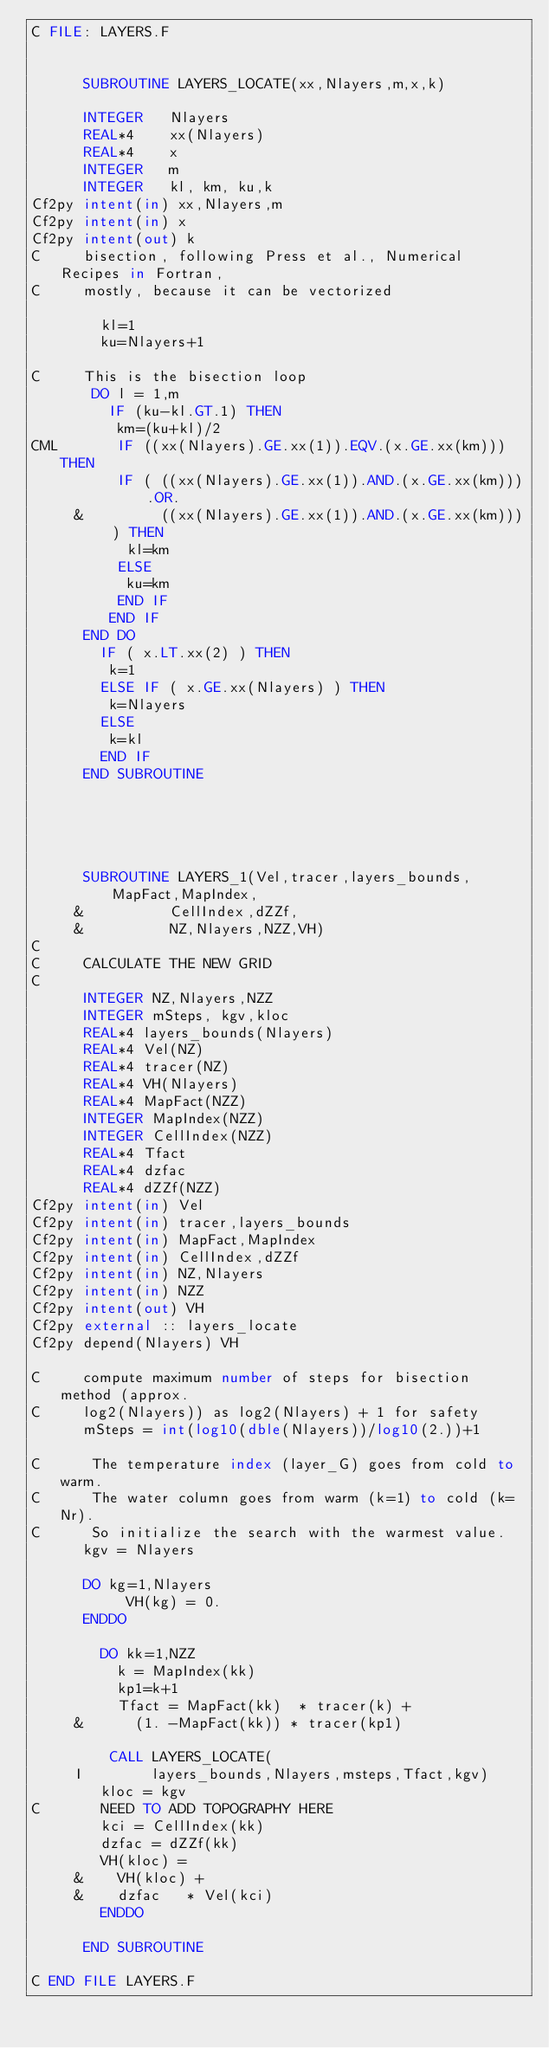<code> <loc_0><loc_0><loc_500><loc_500><_FORTRAN_>C FILE: LAYERS.F


      SUBROUTINE LAYERS_LOCATE(xx,Nlayers,m,x,k)

      INTEGER   Nlayers
      REAL*4    xx(Nlayers)
      REAL*4    x
      INTEGER   m
      INTEGER   kl, km, ku,k
Cf2py intent(in) xx,Nlayers,m
Cf2py intent(in) x
Cf2py intent(out) k
C     bisection, following Press et al., Numerical Recipes in Fortran,
C     mostly, because it can be vectorized

        kl=1
        ku=Nlayers+1
        
C     This is the bisection loop
       DO l = 1,m
         IF (ku-kl.GT.1) THEN
          km=(ku+kl)/2
CML       IF ((xx(Nlayers).GE.xx(1)).EQV.(x.GE.xx(km))) THEN
          IF ( ((xx(Nlayers).GE.xx(1)).AND.(x.GE.xx(km))).OR.
     &         ((xx(Nlayers).GE.xx(1)).AND.(x.GE.xx(km))) ) THEN
           kl=km
          ELSE
           ku=km
          END IF
         END IF
      END DO
        IF ( x.LT.xx(2) ) THEN
         k=1
        ELSE IF ( x.GE.xx(Nlayers) ) THEN
         k=Nlayers
        ELSE
         k=kl
        END IF
      END SUBROUTINE





      SUBROUTINE LAYERS_1(Vel,tracer,layers_bounds,MapFact,MapIndex,
     &          CellIndex,dZZf,
     &          NZ,Nlayers,NZZ,VH)
C     
C     CALCULATE THE NEW GRID
C
      INTEGER NZ,Nlayers,NZZ
      INTEGER mSteps, kgv,kloc
      REAL*4 layers_bounds(Nlayers)
      REAL*4 Vel(NZ)
      REAL*4 tracer(NZ)
      REAL*4 VH(Nlayers)
      REAL*4 MapFact(NZZ)
      INTEGER MapIndex(NZZ)
      INTEGER CellIndex(NZZ)
      REAL*4 Tfact
      REAL*4 dzfac
      REAL*4 dZZf(NZZ)
Cf2py intent(in) Vel
Cf2py intent(in) tracer,layers_bounds
Cf2py intent(in) MapFact,MapIndex
Cf2py intent(in) CellIndex,dZZf
Cf2py intent(in) NZ,Nlayers
Cf2py intent(in) NZZ
Cf2py intent(out) VH
Cf2py external :: layers_locate
Cf2py depend(Nlayers) VH

C     compute maximum number of steps for bisection method (approx.
C     log2(Nlayers)) as log2(Nlayers) + 1 for safety
      mSteps = int(log10(dble(Nlayers))/log10(2.))+1

C      The temperature index (layer_G) goes from cold to warm.
C      The water column goes from warm (k=1) to cold (k=Nr).
C      So initialize the search with the warmest value.
      kgv = Nlayers

      DO kg=1,Nlayers
           VH(kg) = 0. 
      ENDDO
      
        DO kk=1,NZZ
          k = MapIndex(kk)
          kp1=k+1
          Tfact = MapFact(kk)  * tracer(k) +
     &      (1. -MapFact(kk)) * tracer(kp1)
     
         CALL LAYERS_LOCATE(
     I        layers_bounds,Nlayers,msteps,Tfact,kgv)
        kloc = kgv
C       NEED TO ADD TOPOGRAPHY HERE
        kci = CellIndex(kk)
        dzfac = dZZf(kk)
        VH(kloc) =
     &    VH(kloc) +
     &    dzfac   * Vel(kci)
        ENDDO

      END SUBROUTINE

C END FILE LAYERS.F</code> 